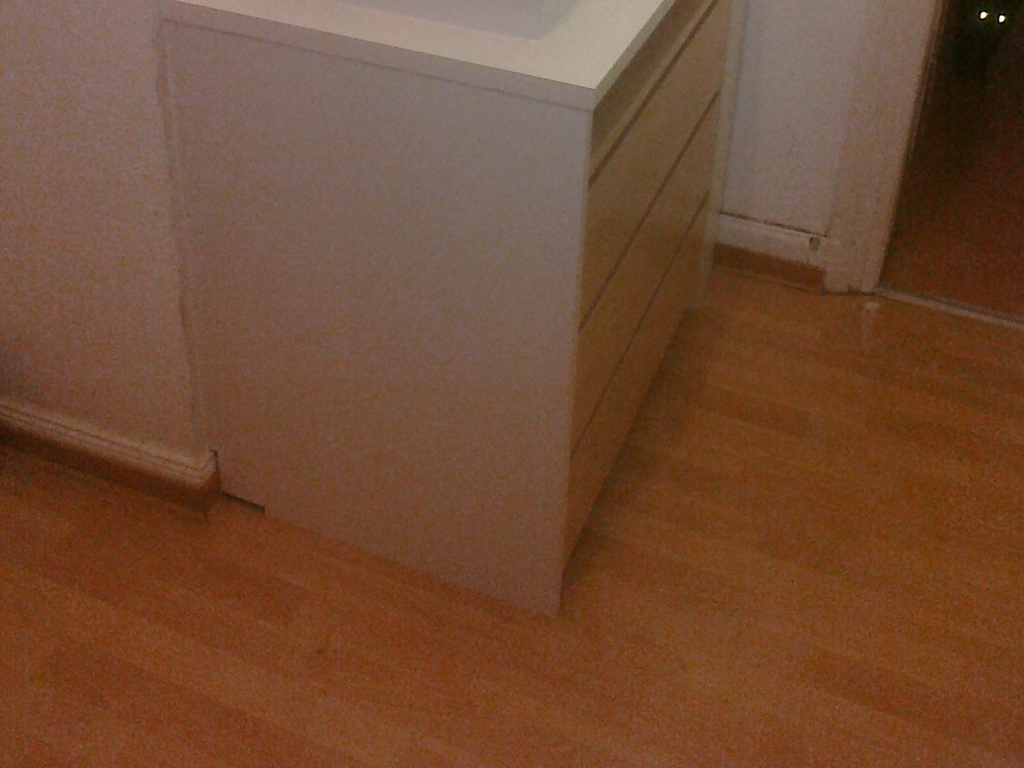Can you describe any details or features about the cabinet design that are noticeable? The cabinet has a sleek, contemporary design characterized by its clean lines and minimalistic appearance. The handles are recessed or possibly integrated, enhancing the cabinet's modern aesthetic. The color seems to be a light hue, likely white or off-white, which contributes to the room's tranquil and uncluttered ambiance. 